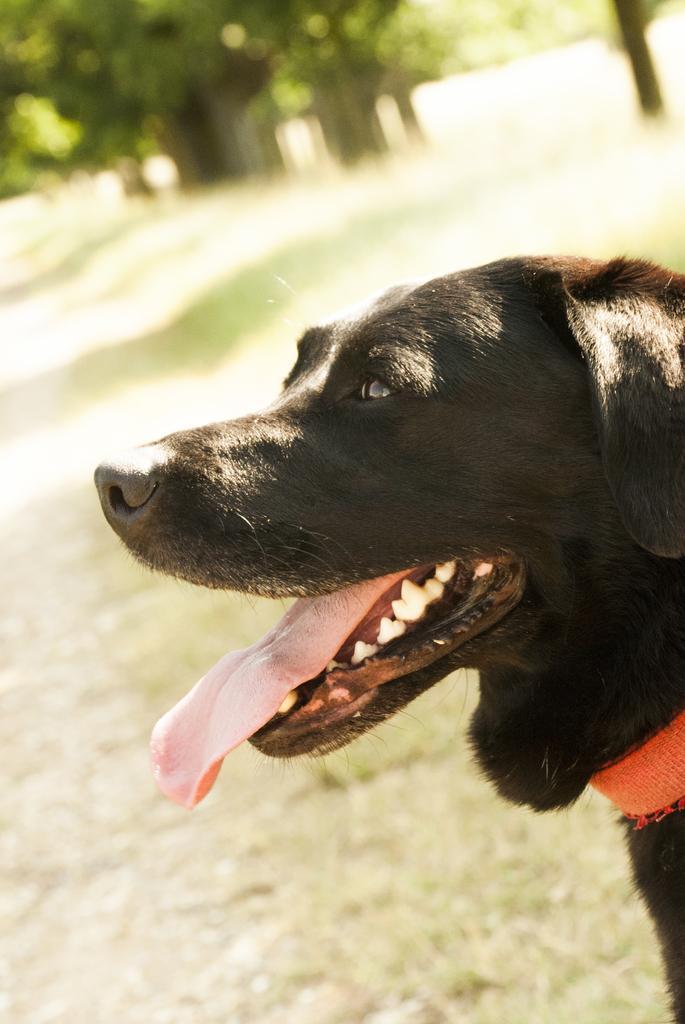Can you describe this image briefly? As we can see in the image in the front there is a black color dog and grass. In the background there are trees. The background is little blurred. 